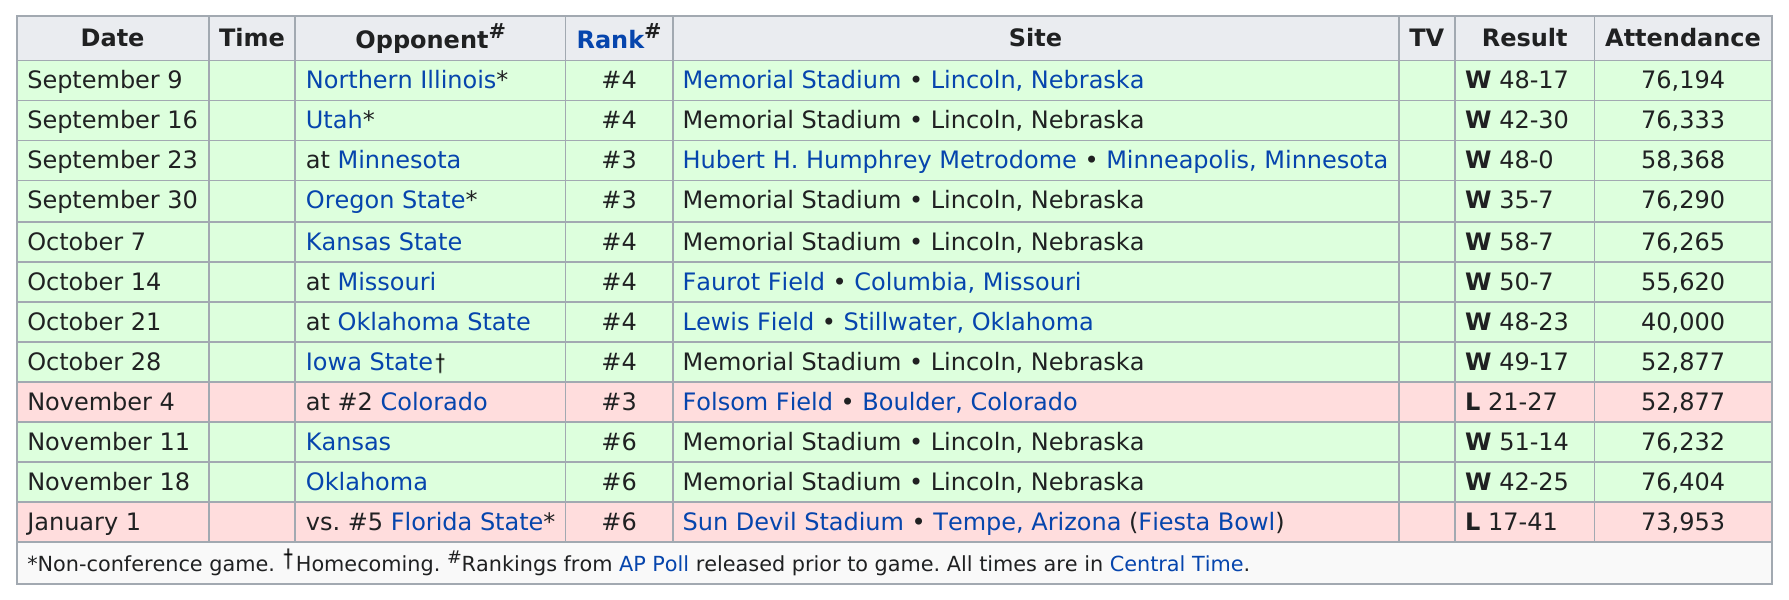Specify some key components in this picture. Out of the total number of games played, how many had attendance above 70,000? Subsequent to Oklahoma State, the game will feature Iowa State. The first game will take place on September 9th. January is the month that is listed the least on this chart. The ranking was not lower than #5 for as many games as 9. 